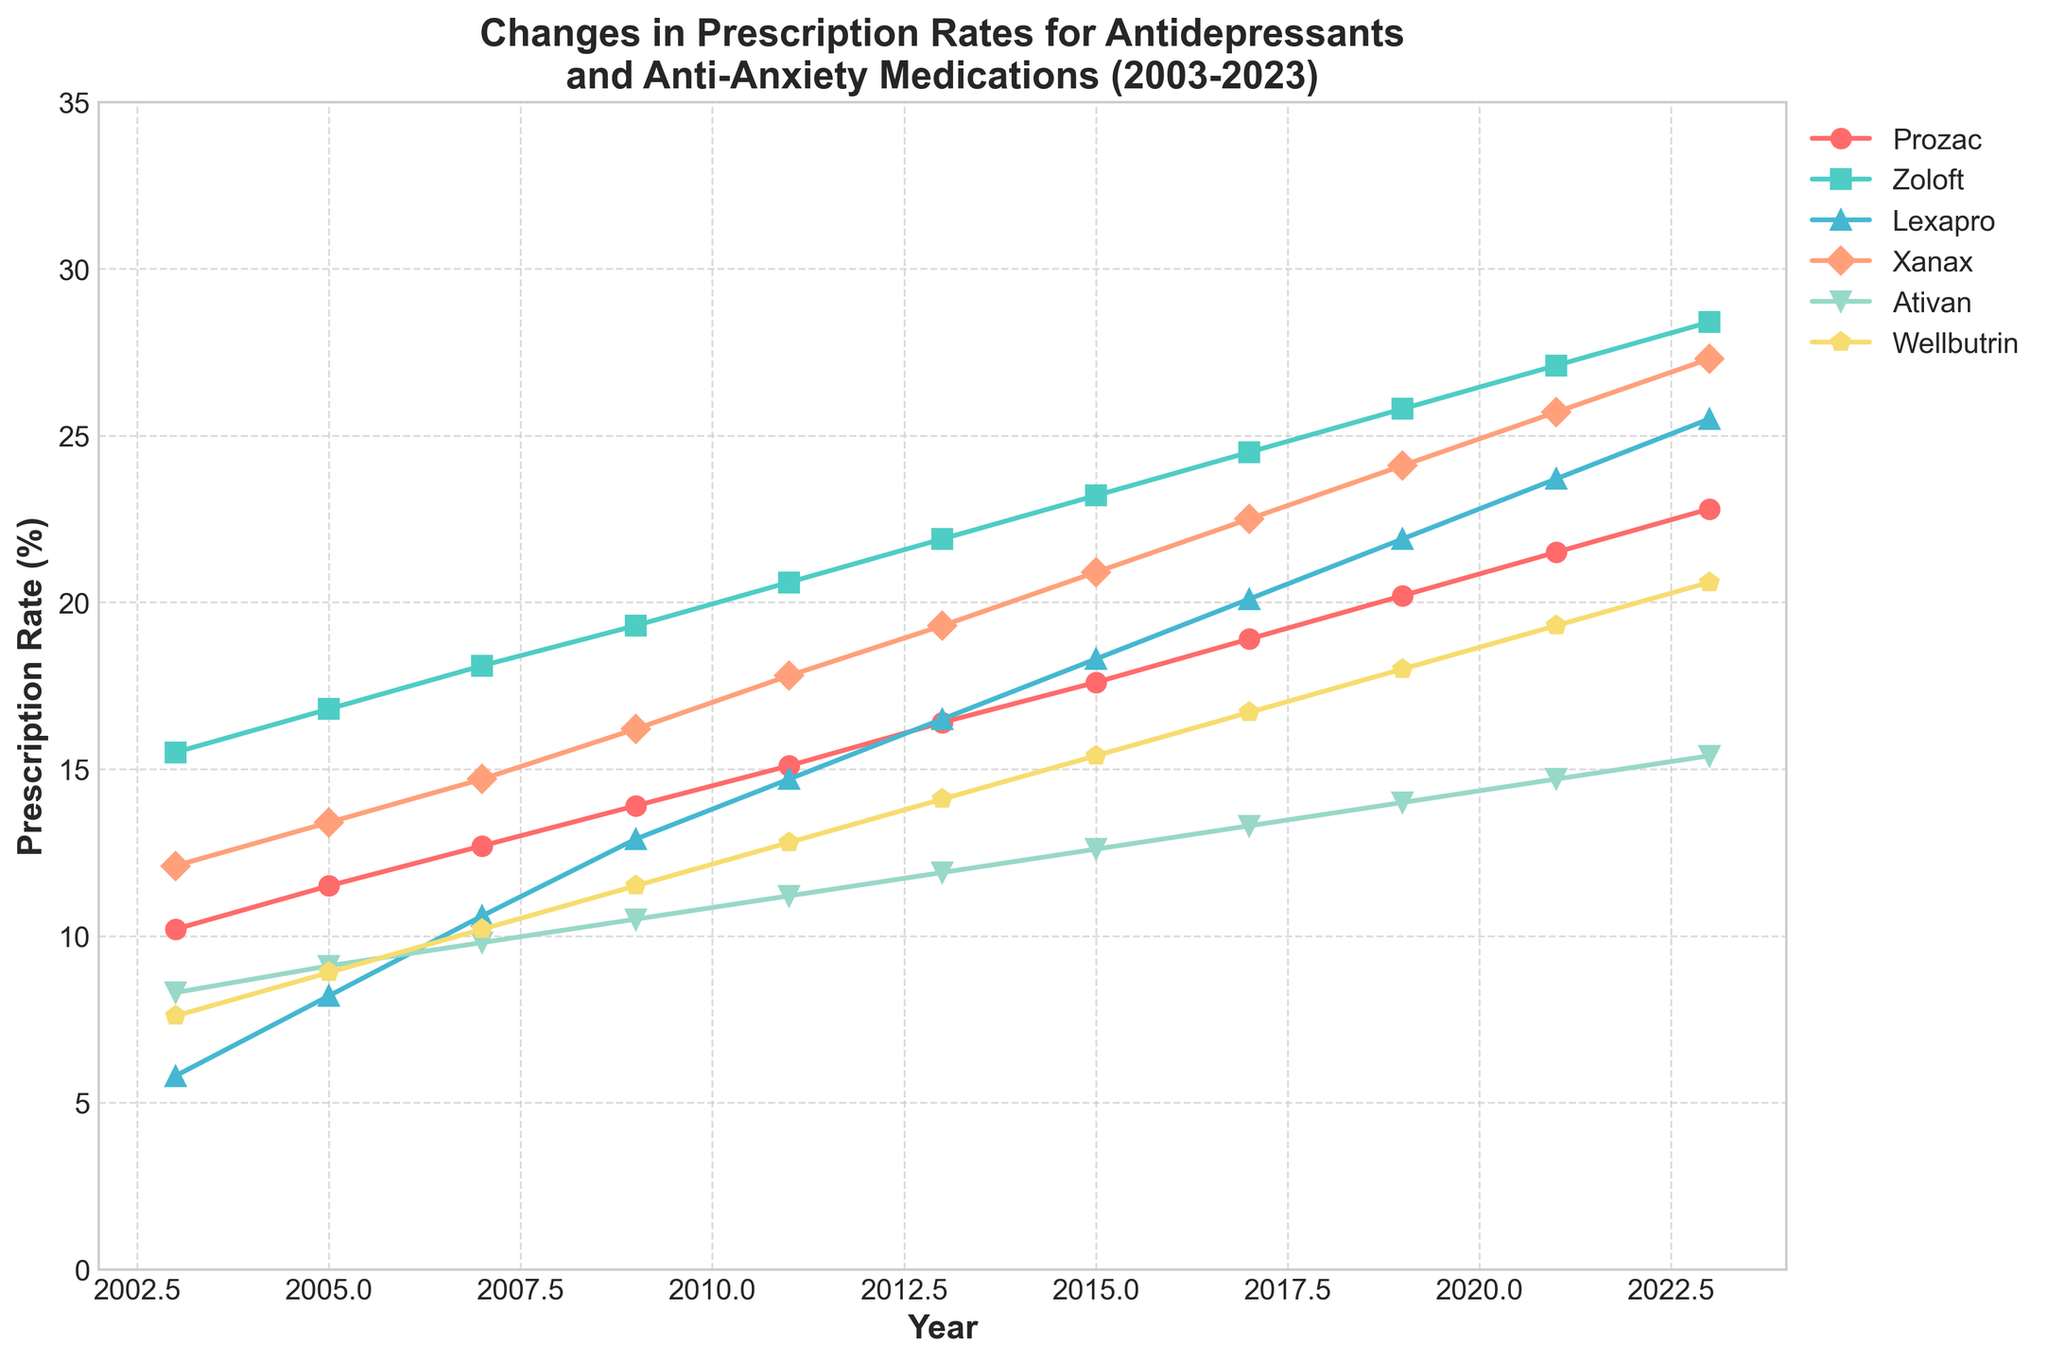What is the overall trend in the prescription rates for Prozac from 2003 to 2023? The prescription rate for Prozac steadily increases each year on the plot, indicating a general upward trend over the 20 years.
Answer: Steady increase Which medication has the highest prescription rate in 2023? By looking at the end of the 2023 lines, Zoloft appears to have the highest prescription rate compared to the other medications.
Answer: Zoloft Between Xanax and Lexapro, which medication experienced a more significant increase from 2003 to 2023? Xanax started at 12.1% in 2003 and reached 27.3% in 2023, a difference of 15.2%. Lexapro started at 5.8% in 2003 and reached 25.5% in 2023, a 19.7% increase. Lexapro experienced a more significant increase.
Answer: Lexapro What can you infer about the prescription rates for Ativan compared to Wellbutrin from 2011 to 2023? In 2011, Ativan's rate was 11.2% and Wellbutrin's was 12.8%. By 2023, Ativan reached 15.4%, and Wellbutrin reached 20.6%. Wellbutrin consistently had higher rates and increased more significantly.
Answer: Wellbutrin's rate is consistently higher and increases more How did the prescription rate for Zoloft compare with that of Prozac in 2009? In 2009, Zoloft had a prescription rate of 19.3%, and Prozac had a rate of 13.9%, making Zoloft's rate higher.
Answer: Zoloft's rate is higher What is the average prescription rate of Wellbutrin over the years shown in the plot? The prescription rates of Wellbutrin from 2003 to 2023 are summed, and the average is calculated: (7.6 + 8.9 + 10.2 + 11.5 + 12.8 + 14.1 + 15.4 + 16.7 + 18 + 19.3 + 20.6) / 11 = 14.5%.
Answer: 14.5% Which medication had the least significant increase in prescription rates over the 20-year period? Prozac started at 10.2% in 2003 and reached 22.8% in 2023, an increase of 12.6%. Comparing with other medications, Prozac had the least significant increase.
Answer: Prozac If the rates for all medications continue to follow the same trends, which medication will likely have the highest prescription rate in 2025? Zoloft consistently leads in prescription rates. If the same trend continues, Zoloft will likely have the highest rate in 2025.
Answer: Zoloft Was there any year when Xanax and Ativan had the same prescription rates? By examining the lines closely, there is no point shown where the prescription rates for Xanax and Ativan intersect or are the same.
Answer: No 